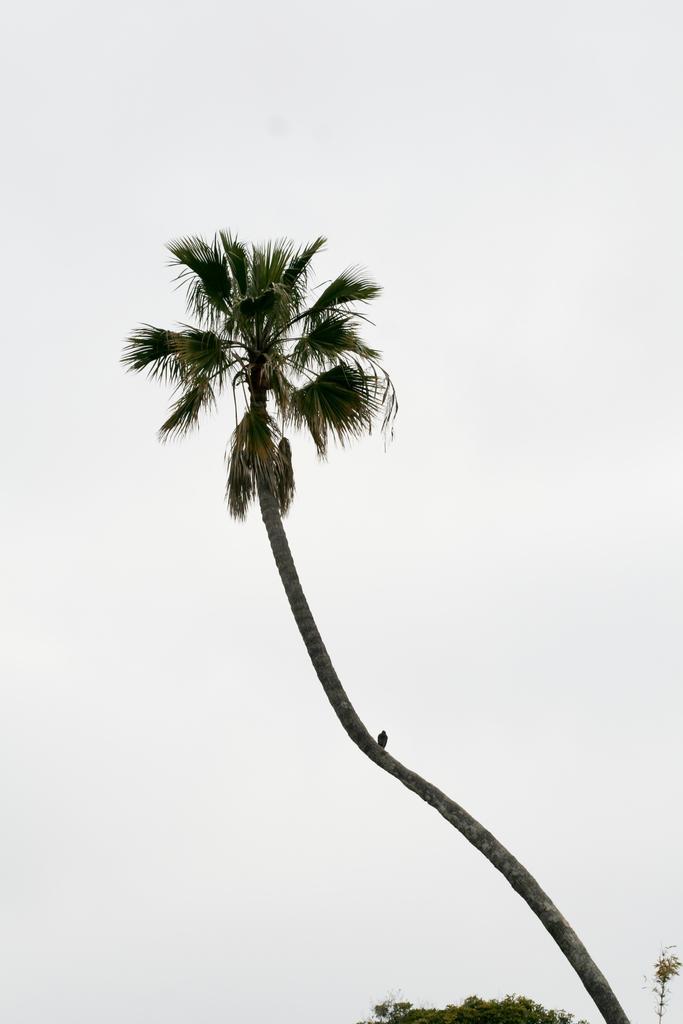In one or two sentences, can you explain what this image depicts? In this picture we can see a bird on a tree and green leaves. In the background it is white. 